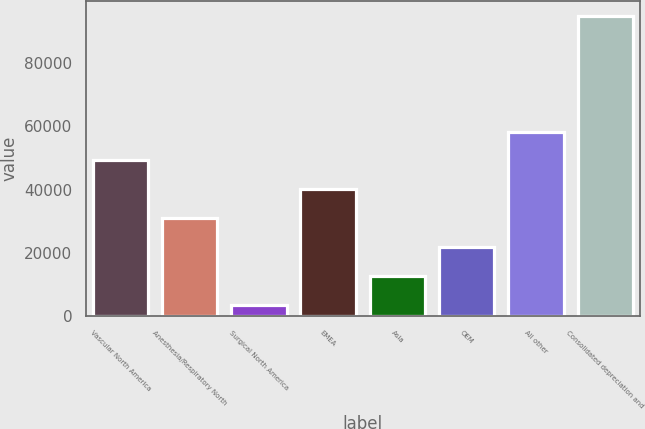Convert chart. <chart><loc_0><loc_0><loc_500><loc_500><bar_chart><fcel>Vascular North America<fcel>Anesthesia/Respiratory North<fcel>Surgical North America<fcel>EMEA<fcel>Asia<fcel>OEM<fcel>All other<fcel>Consolidated depreciation and<nl><fcel>49265<fcel>31017.4<fcel>3646<fcel>40141.2<fcel>12769.8<fcel>21893.6<fcel>58388.8<fcel>94884<nl></chart> 